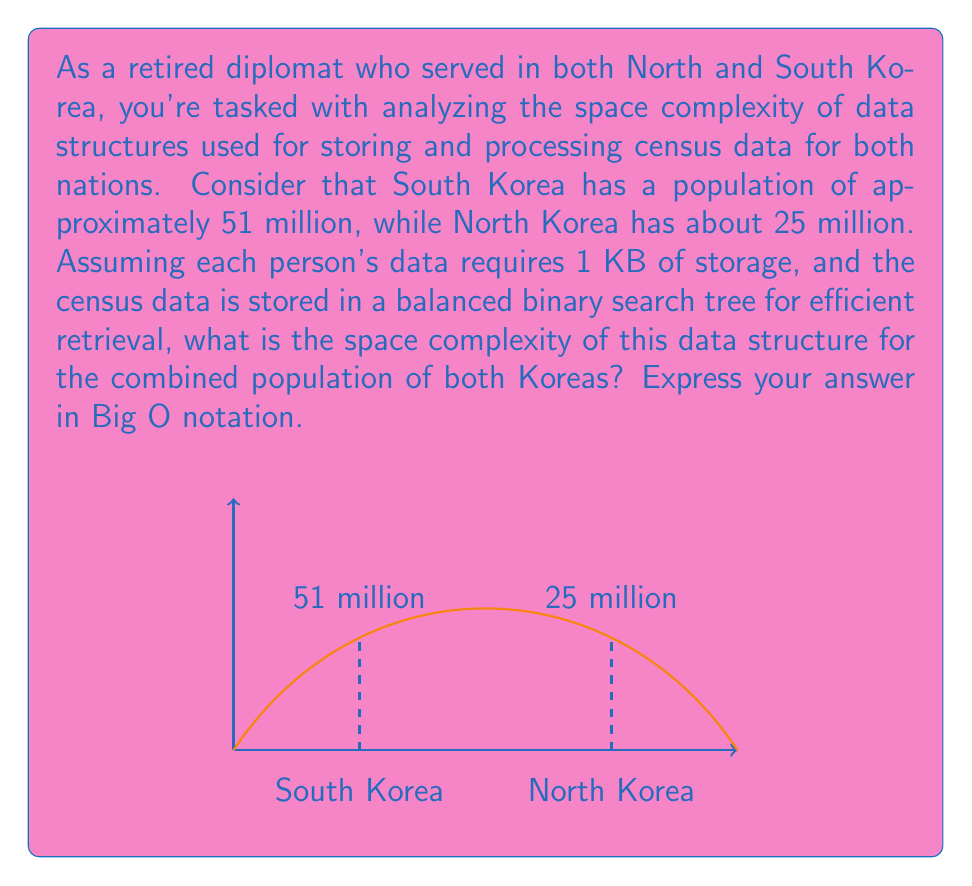Could you help me with this problem? Let's approach this step-by-step:

1) First, we need to calculate the total population:
   $$ \text{Total population} = 51 \text{ million} + 25 \text{ million} = 76 \text{ million} $$

2) In a balanced binary search tree, each node represents one person's data. The number of nodes is equal to the total population, which we'll call $n$.

3) The space complexity of a balanced binary search tree is $O(n)$, where $n$ is the number of nodes. This is because the tree needs to store all the data elements.

4) However, we also need to consider the space required for each person's data:
   $$ \text{Space per person} = 1 \text{ KB} = 1024 \text{ bytes} $$

5) The total space required is:
   $$ \text{Total space} = n * 1024 \text{ bytes} $$

6) In Big O notation, constant factors are ignored. Therefore, the 1024 bytes per person doesn't affect the overall complexity.

7) Additionally, the exact population (76 million) is not relevant for Big O notation. We're interested in how the space requirements grow with respect to the input size.

Therefore, the space complexity remains $O(n)$, where $n$ represents the total population.
Answer: $O(n)$ 